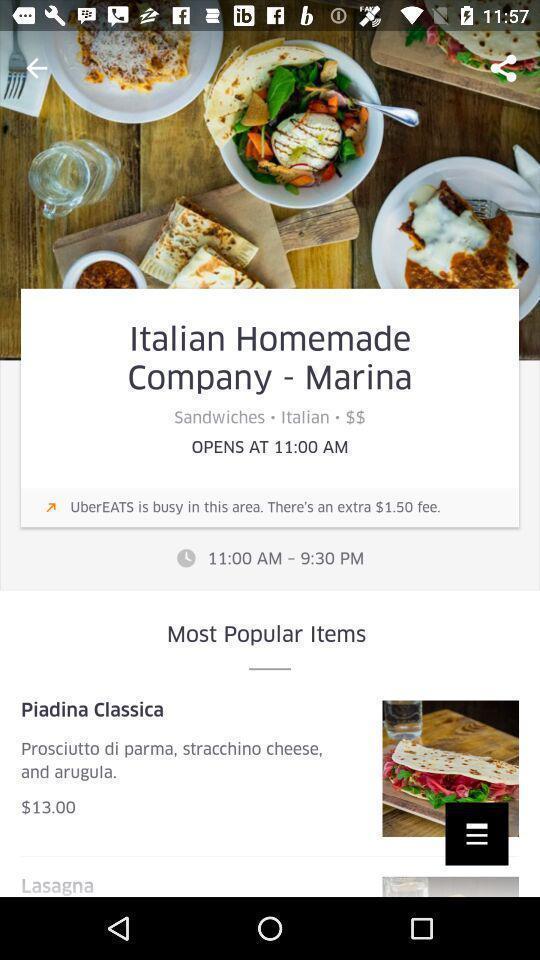Give me a summary of this screen capture. Page displaying the timings of a food delivery app. 